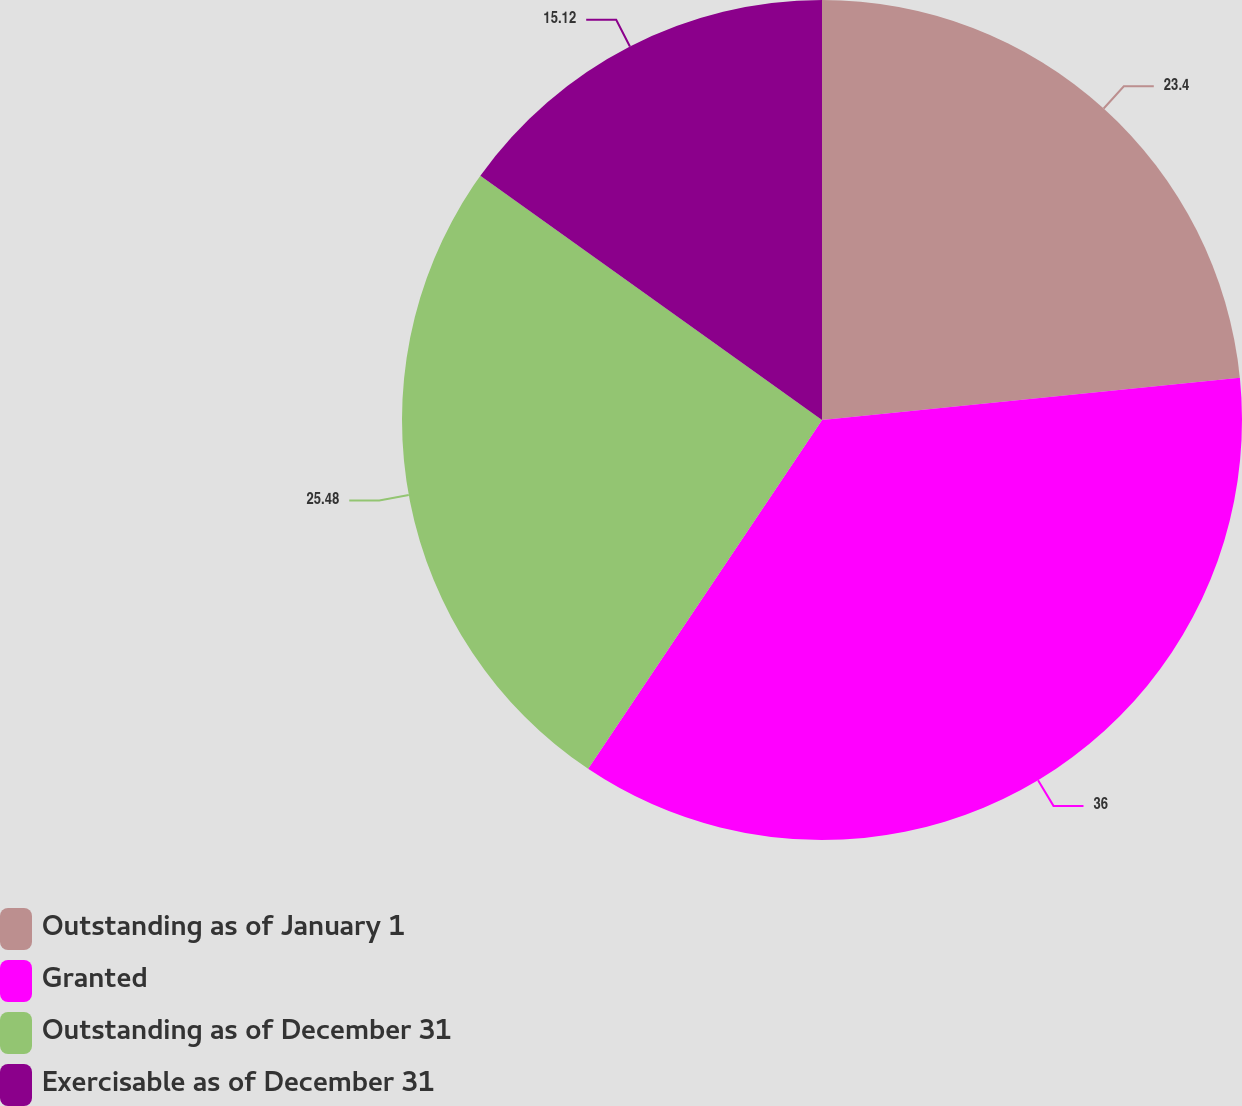Convert chart to OTSL. <chart><loc_0><loc_0><loc_500><loc_500><pie_chart><fcel>Outstanding as of January 1<fcel>Granted<fcel>Outstanding as of December 31<fcel>Exercisable as of December 31<nl><fcel>23.4%<fcel>36.0%<fcel>25.48%<fcel>15.12%<nl></chart> 